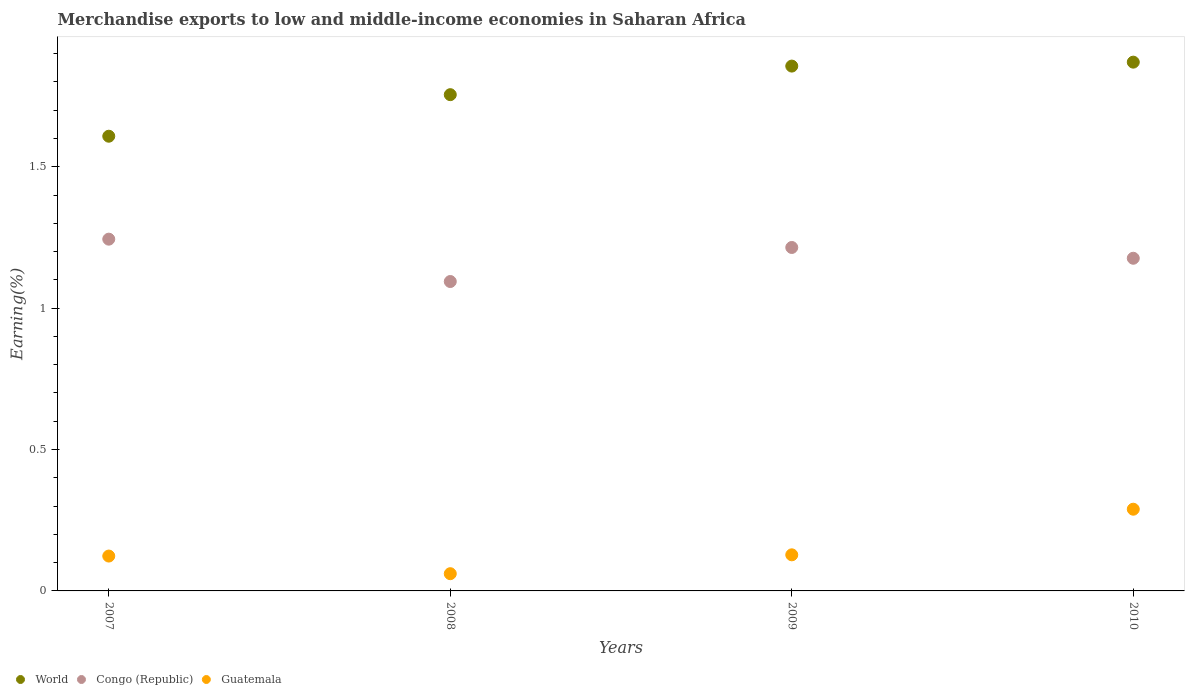What is the percentage of amount earned from merchandise exports in World in 2007?
Provide a succinct answer. 1.61. Across all years, what is the maximum percentage of amount earned from merchandise exports in World?
Your answer should be compact. 1.87. Across all years, what is the minimum percentage of amount earned from merchandise exports in World?
Ensure brevity in your answer.  1.61. In which year was the percentage of amount earned from merchandise exports in Congo (Republic) maximum?
Your response must be concise. 2007. In which year was the percentage of amount earned from merchandise exports in Congo (Republic) minimum?
Offer a terse response. 2008. What is the total percentage of amount earned from merchandise exports in World in the graph?
Keep it short and to the point. 7.09. What is the difference between the percentage of amount earned from merchandise exports in World in 2007 and that in 2010?
Keep it short and to the point. -0.26. What is the difference between the percentage of amount earned from merchandise exports in Congo (Republic) in 2009 and the percentage of amount earned from merchandise exports in Guatemala in 2007?
Your answer should be compact. 1.09. What is the average percentage of amount earned from merchandise exports in Congo (Republic) per year?
Make the answer very short. 1.18. In the year 2010, what is the difference between the percentage of amount earned from merchandise exports in Guatemala and percentage of amount earned from merchandise exports in World?
Make the answer very short. -1.58. What is the ratio of the percentage of amount earned from merchandise exports in Guatemala in 2008 to that in 2009?
Offer a terse response. 0.48. What is the difference between the highest and the second highest percentage of amount earned from merchandise exports in Congo (Republic)?
Offer a very short reply. 0.03. What is the difference between the highest and the lowest percentage of amount earned from merchandise exports in World?
Your answer should be compact. 0.26. In how many years, is the percentage of amount earned from merchandise exports in Guatemala greater than the average percentage of amount earned from merchandise exports in Guatemala taken over all years?
Offer a terse response. 1. Is the percentage of amount earned from merchandise exports in World strictly greater than the percentage of amount earned from merchandise exports in Congo (Republic) over the years?
Your answer should be compact. Yes. What is the difference between two consecutive major ticks on the Y-axis?
Offer a very short reply. 0.5. How are the legend labels stacked?
Provide a succinct answer. Horizontal. What is the title of the graph?
Keep it short and to the point. Merchandise exports to low and middle-income economies in Saharan Africa. Does "Tuvalu" appear as one of the legend labels in the graph?
Keep it short and to the point. No. What is the label or title of the Y-axis?
Provide a succinct answer. Earning(%). What is the Earning(%) of World in 2007?
Make the answer very short. 1.61. What is the Earning(%) of Congo (Republic) in 2007?
Offer a very short reply. 1.24. What is the Earning(%) in Guatemala in 2007?
Offer a very short reply. 0.12. What is the Earning(%) of World in 2008?
Your answer should be compact. 1.75. What is the Earning(%) of Congo (Republic) in 2008?
Ensure brevity in your answer.  1.09. What is the Earning(%) of Guatemala in 2008?
Provide a short and direct response. 0.06. What is the Earning(%) of World in 2009?
Provide a succinct answer. 1.86. What is the Earning(%) in Congo (Republic) in 2009?
Offer a very short reply. 1.21. What is the Earning(%) in Guatemala in 2009?
Ensure brevity in your answer.  0.13. What is the Earning(%) in World in 2010?
Offer a terse response. 1.87. What is the Earning(%) in Congo (Republic) in 2010?
Provide a succinct answer. 1.18. What is the Earning(%) in Guatemala in 2010?
Your answer should be compact. 0.29. Across all years, what is the maximum Earning(%) in World?
Your answer should be very brief. 1.87. Across all years, what is the maximum Earning(%) in Congo (Republic)?
Ensure brevity in your answer.  1.24. Across all years, what is the maximum Earning(%) in Guatemala?
Offer a very short reply. 0.29. Across all years, what is the minimum Earning(%) in World?
Make the answer very short. 1.61. Across all years, what is the minimum Earning(%) in Congo (Republic)?
Your answer should be compact. 1.09. Across all years, what is the minimum Earning(%) in Guatemala?
Offer a very short reply. 0.06. What is the total Earning(%) of World in the graph?
Your answer should be very brief. 7.09. What is the total Earning(%) in Congo (Republic) in the graph?
Offer a terse response. 4.73. What is the total Earning(%) of Guatemala in the graph?
Provide a short and direct response. 0.6. What is the difference between the Earning(%) in World in 2007 and that in 2008?
Provide a short and direct response. -0.15. What is the difference between the Earning(%) of Congo (Republic) in 2007 and that in 2008?
Your response must be concise. 0.15. What is the difference between the Earning(%) of Guatemala in 2007 and that in 2008?
Offer a very short reply. 0.06. What is the difference between the Earning(%) of World in 2007 and that in 2009?
Offer a terse response. -0.25. What is the difference between the Earning(%) in Congo (Republic) in 2007 and that in 2009?
Keep it short and to the point. 0.03. What is the difference between the Earning(%) in Guatemala in 2007 and that in 2009?
Your answer should be very brief. -0. What is the difference between the Earning(%) in World in 2007 and that in 2010?
Your answer should be very brief. -0.26. What is the difference between the Earning(%) in Congo (Republic) in 2007 and that in 2010?
Offer a terse response. 0.07. What is the difference between the Earning(%) of Guatemala in 2007 and that in 2010?
Offer a terse response. -0.17. What is the difference between the Earning(%) in World in 2008 and that in 2009?
Make the answer very short. -0.1. What is the difference between the Earning(%) of Congo (Republic) in 2008 and that in 2009?
Your answer should be compact. -0.12. What is the difference between the Earning(%) in Guatemala in 2008 and that in 2009?
Your answer should be very brief. -0.07. What is the difference between the Earning(%) of World in 2008 and that in 2010?
Your answer should be very brief. -0.12. What is the difference between the Earning(%) of Congo (Republic) in 2008 and that in 2010?
Your response must be concise. -0.08. What is the difference between the Earning(%) of Guatemala in 2008 and that in 2010?
Make the answer very short. -0.23. What is the difference between the Earning(%) in World in 2009 and that in 2010?
Your response must be concise. -0.01. What is the difference between the Earning(%) in Congo (Republic) in 2009 and that in 2010?
Provide a short and direct response. 0.04. What is the difference between the Earning(%) in Guatemala in 2009 and that in 2010?
Your response must be concise. -0.16. What is the difference between the Earning(%) in World in 2007 and the Earning(%) in Congo (Republic) in 2008?
Your answer should be very brief. 0.51. What is the difference between the Earning(%) of World in 2007 and the Earning(%) of Guatemala in 2008?
Your response must be concise. 1.55. What is the difference between the Earning(%) of Congo (Republic) in 2007 and the Earning(%) of Guatemala in 2008?
Ensure brevity in your answer.  1.18. What is the difference between the Earning(%) in World in 2007 and the Earning(%) in Congo (Republic) in 2009?
Provide a short and direct response. 0.39. What is the difference between the Earning(%) of World in 2007 and the Earning(%) of Guatemala in 2009?
Give a very brief answer. 1.48. What is the difference between the Earning(%) of Congo (Republic) in 2007 and the Earning(%) of Guatemala in 2009?
Offer a very short reply. 1.12. What is the difference between the Earning(%) of World in 2007 and the Earning(%) of Congo (Republic) in 2010?
Offer a very short reply. 0.43. What is the difference between the Earning(%) in World in 2007 and the Earning(%) in Guatemala in 2010?
Your response must be concise. 1.32. What is the difference between the Earning(%) in Congo (Republic) in 2007 and the Earning(%) in Guatemala in 2010?
Provide a short and direct response. 0.95. What is the difference between the Earning(%) of World in 2008 and the Earning(%) of Congo (Republic) in 2009?
Offer a very short reply. 0.54. What is the difference between the Earning(%) of World in 2008 and the Earning(%) of Guatemala in 2009?
Your response must be concise. 1.63. What is the difference between the Earning(%) of Congo (Republic) in 2008 and the Earning(%) of Guatemala in 2009?
Your answer should be compact. 0.97. What is the difference between the Earning(%) in World in 2008 and the Earning(%) in Congo (Republic) in 2010?
Your answer should be very brief. 0.58. What is the difference between the Earning(%) of World in 2008 and the Earning(%) of Guatemala in 2010?
Your answer should be very brief. 1.47. What is the difference between the Earning(%) of Congo (Republic) in 2008 and the Earning(%) of Guatemala in 2010?
Ensure brevity in your answer.  0.81. What is the difference between the Earning(%) in World in 2009 and the Earning(%) in Congo (Republic) in 2010?
Ensure brevity in your answer.  0.68. What is the difference between the Earning(%) of World in 2009 and the Earning(%) of Guatemala in 2010?
Provide a succinct answer. 1.57. What is the difference between the Earning(%) in Congo (Republic) in 2009 and the Earning(%) in Guatemala in 2010?
Offer a very short reply. 0.93. What is the average Earning(%) of World per year?
Provide a succinct answer. 1.77. What is the average Earning(%) of Congo (Republic) per year?
Your answer should be very brief. 1.18. What is the average Earning(%) of Guatemala per year?
Provide a succinct answer. 0.15. In the year 2007, what is the difference between the Earning(%) in World and Earning(%) in Congo (Republic)?
Provide a succinct answer. 0.36. In the year 2007, what is the difference between the Earning(%) of World and Earning(%) of Guatemala?
Keep it short and to the point. 1.48. In the year 2007, what is the difference between the Earning(%) of Congo (Republic) and Earning(%) of Guatemala?
Give a very brief answer. 1.12. In the year 2008, what is the difference between the Earning(%) in World and Earning(%) in Congo (Republic)?
Offer a terse response. 0.66. In the year 2008, what is the difference between the Earning(%) of World and Earning(%) of Guatemala?
Give a very brief answer. 1.69. In the year 2008, what is the difference between the Earning(%) in Congo (Republic) and Earning(%) in Guatemala?
Offer a terse response. 1.03. In the year 2009, what is the difference between the Earning(%) in World and Earning(%) in Congo (Republic)?
Offer a very short reply. 0.64. In the year 2009, what is the difference between the Earning(%) in World and Earning(%) in Guatemala?
Ensure brevity in your answer.  1.73. In the year 2009, what is the difference between the Earning(%) of Congo (Republic) and Earning(%) of Guatemala?
Give a very brief answer. 1.09. In the year 2010, what is the difference between the Earning(%) in World and Earning(%) in Congo (Republic)?
Provide a succinct answer. 0.69. In the year 2010, what is the difference between the Earning(%) of World and Earning(%) of Guatemala?
Offer a terse response. 1.58. In the year 2010, what is the difference between the Earning(%) in Congo (Republic) and Earning(%) in Guatemala?
Make the answer very short. 0.89. What is the ratio of the Earning(%) of World in 2007 to that in 2008?
Ensure brevity in your answer.  0.92. What is the ratio of the Earning(%) of Congo (Republic) in 2007 to that in 2008?
Offer a very short reply. 1.14. What is the ratio of the Earning(%) of Guatemala in 2007 to that in 2008?
Provide a succinct answer. 2.02. What is the ratio of the Earning(%) in World in 2007 to that in 2009?
Your answer should be compact. 0.87. What is the ratio of the Earning(%) of Congo (Republic) in 2007 to that in 2009?
Make the answer very short. 1.02. What is the ratio of the Earning(%) of Guatemala in 2007 to that in 2009?
Your answer should be very brief. 0.97. What is the ratio of the Earning(%) of World in 2007 to that in 2010?
Offer a very short reply. 0.86. What is the ratio of the Earning(%) in Congo (Republic) in 2007 to that in 2010?
Your answer should be compact. 1.06. What is the ratio of the Earning(%) in Guatemala in 2007 to that in 2010?
Provide a short and direct response. 0.43. What is the ratio of the Earning(%) of World in 2008 to that in 2009?
Ensure brevity in your answer.  0.95. What is the ratio of the Earning(%) in Congo (Republic) in 2008 to that in 2009?
Provide a short and direct response. 0.9. What is the ratio of the Earning(%) of Guatemala in 2008 to that in 2009?
Your response must be concise. 0.48. What is the ratio of the Earning(%) of World in 2008 to that in 2010?
Keep it short and to the point. 0.94. What is the ratio of the Earning(%) in Congo (Republic) in 2008 to that in 2010?
Offer a very short reply. 0.93. What is the ratio of the Earning(%) of Guatemala in 2008 to that in 2010?
Provide a succinct answer. 0.21. What is the ratio of the Earning(%) in Congo (Republic) in 2009 to that in 2010?
Your response must be concise. 1.03. What is the ratio of the Earning(%) of Guatemala in 2009 to that in 2010?
Your answer should be very brief. 0.44. What is the difference between the highest and the second highest Earning(%) of World?
Offer a terse response. 0.01. What is the difference between the highest and the second highest Earning(%) in Congo (Republic)?
Make the answer very short. 0.03. What is the difference between the highest and the second highest Earning(%) in Guatemala?
Provide a short and direct response. 0.16. What is the difference between the highest and the lowest Earning(%) of World?
Your response must be concise. 0.26. What is the difference between the highest and the lowest Earning(%) in Congo (Republic)?
Give a very brief answer. 0.15. What is the difference between the highest and the lowest Earning(%) of Guatemala?
Ensure brevity in your answer.  0.23. 